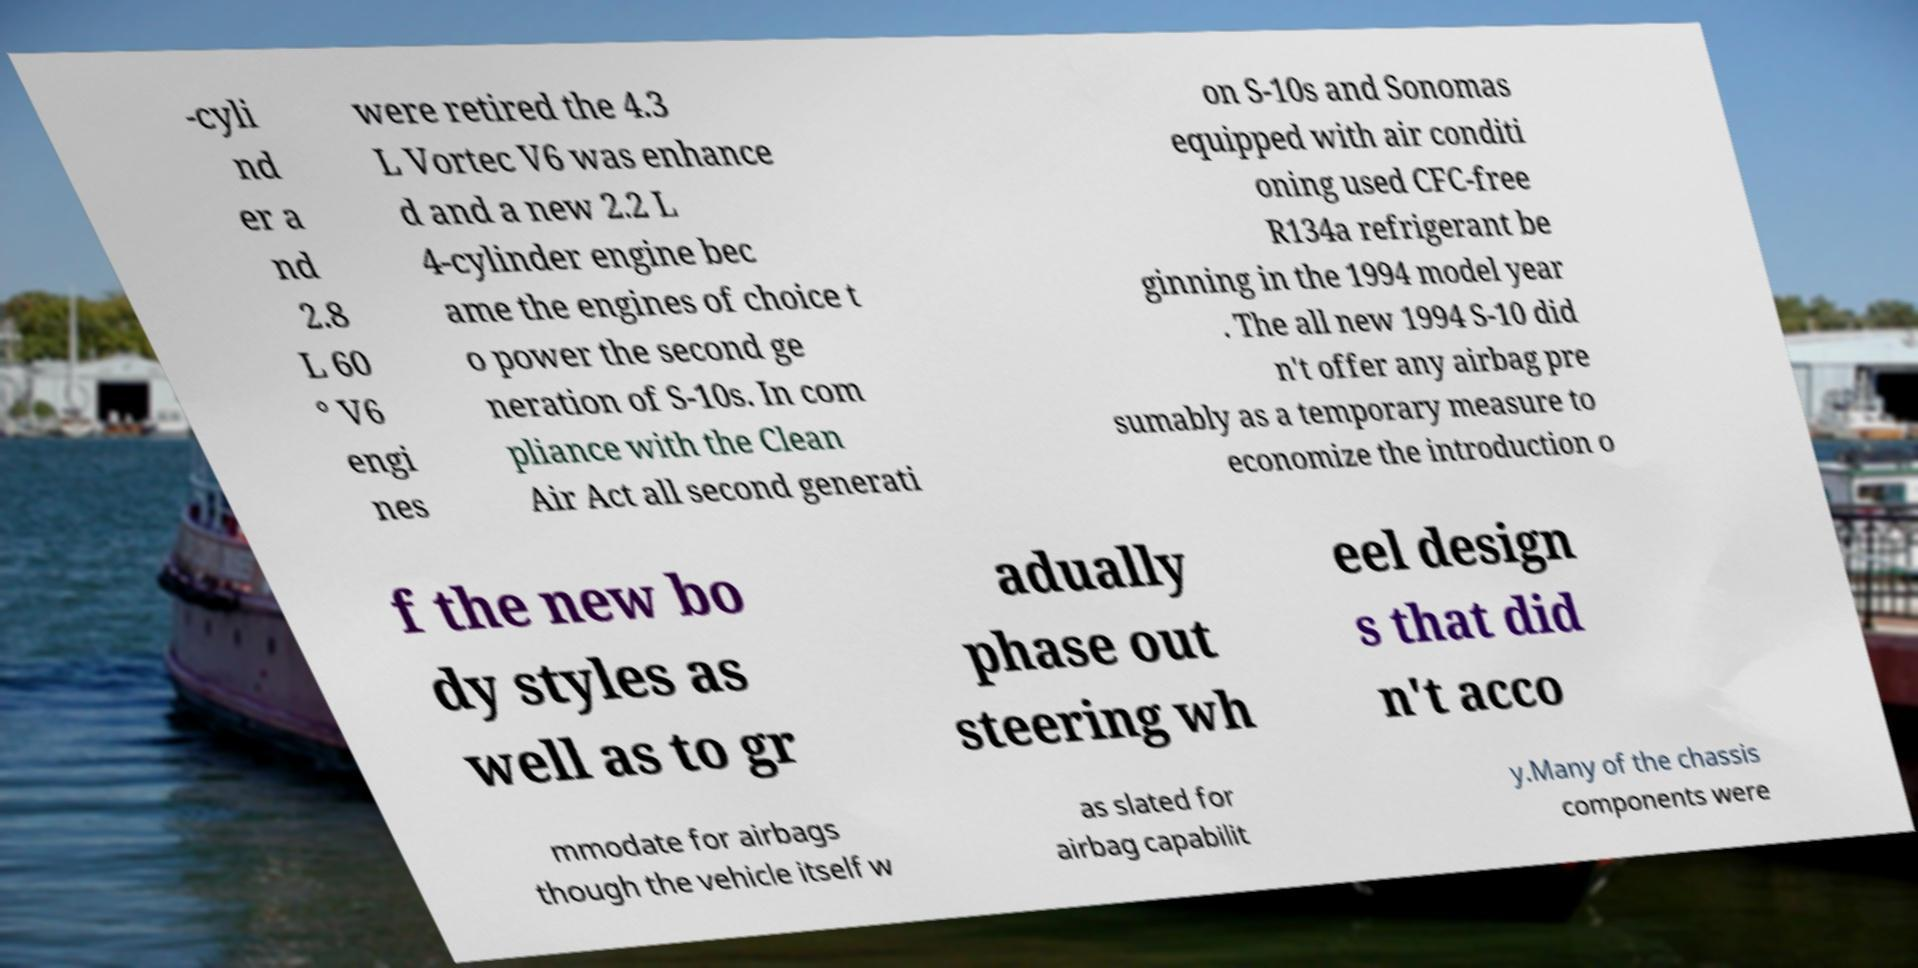Please identify and transcribe the text found in this image. -cyli nd er a nd 2.8 L 60 ° V6 engi nes were retired the 4.3 L Vortec V6 was enhance d and a new 2.2 L 4-cylinder engine bec ame the engines of choice t o power the second ge neration of S-10s. In com pliance with the Clean Air Act all second generati on S-10s and Sonomas equipped with air conditi oning used CFC-free R134a refrigerant be ginning in the 1994 model year . The all new 1994 S-10 did n't offer any airbag pre sumably as a temporary measure to economize the introduction o f the new bo dy styles as well as to gr adually phase out steering wh eel design s that did n't acco mmodate for airbags though the vehicle itself w as slated for airbag capabilit y.Many of the chassis components were 